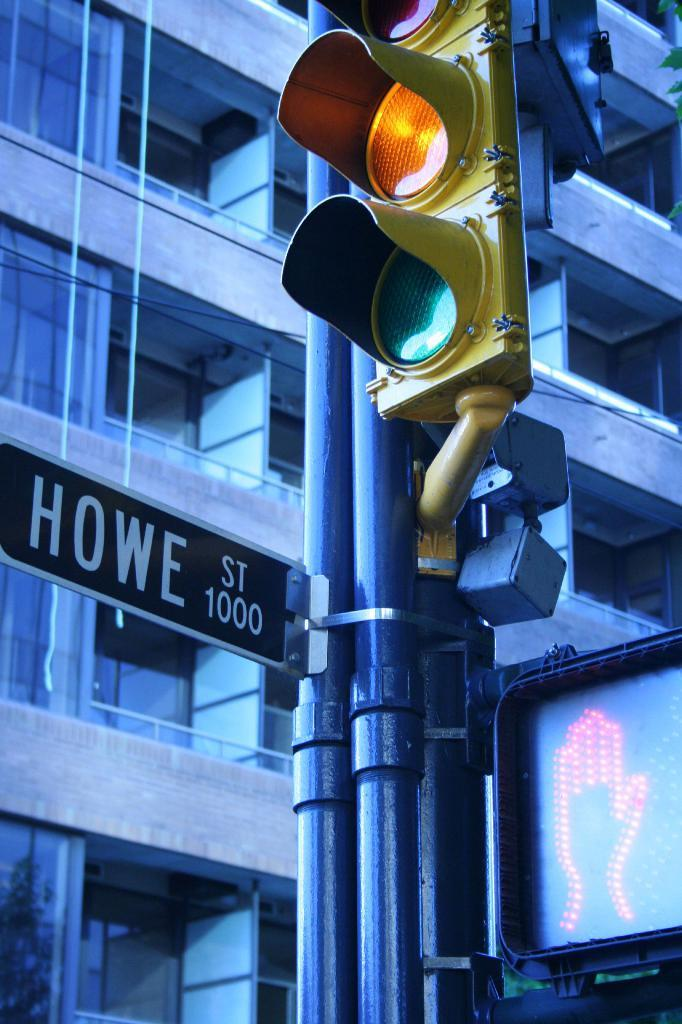Provide a one-sentence caption for the provided image. A yellow light and a do not walk signal are lit on Howe St. 